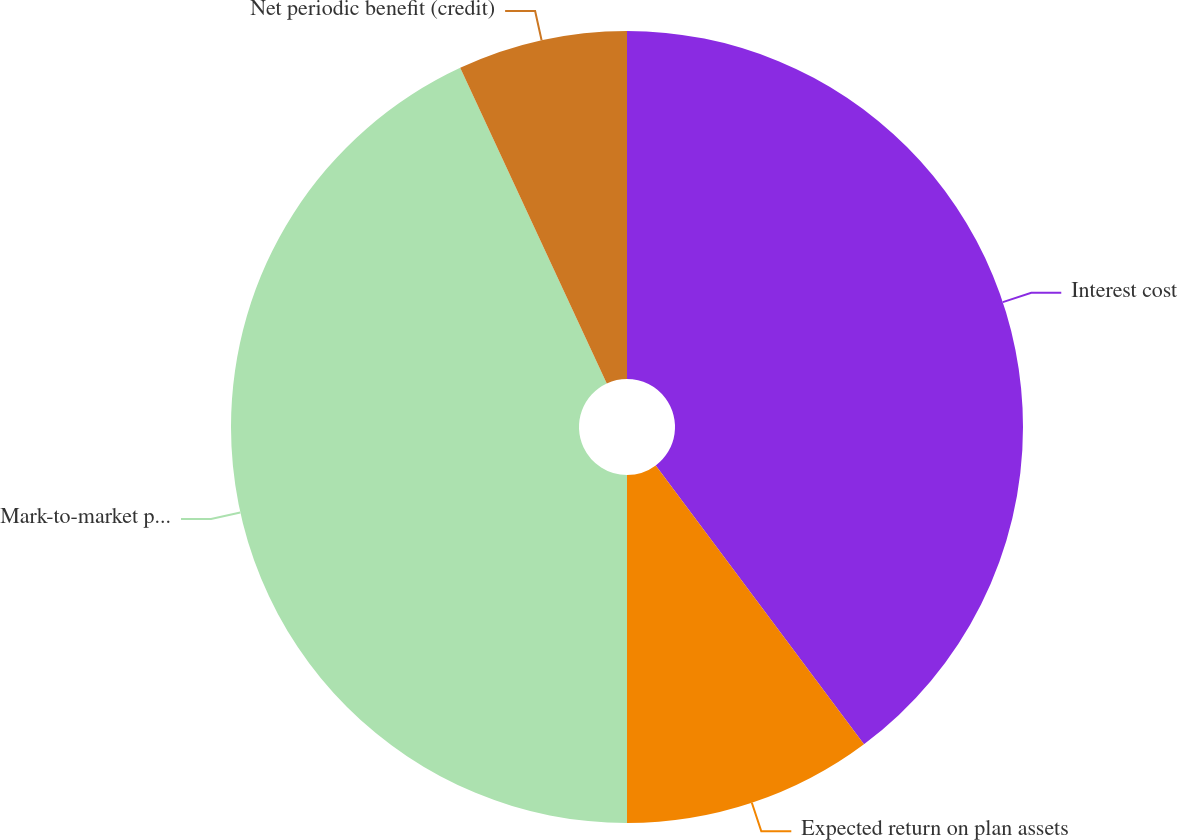Convert chart. <chart><loc_0><loc_0><loc_500><loc_500><pie_chart><fcel>Interest cost<fcel>Expected return on plan assets<fcel>Mark-to-market pension and<fcel>Net periodic benefit (credit)<nl><fcel>39.79%<fcel>10.21%<fcel>43.08%<fcel>6.92%<nl></chart> 